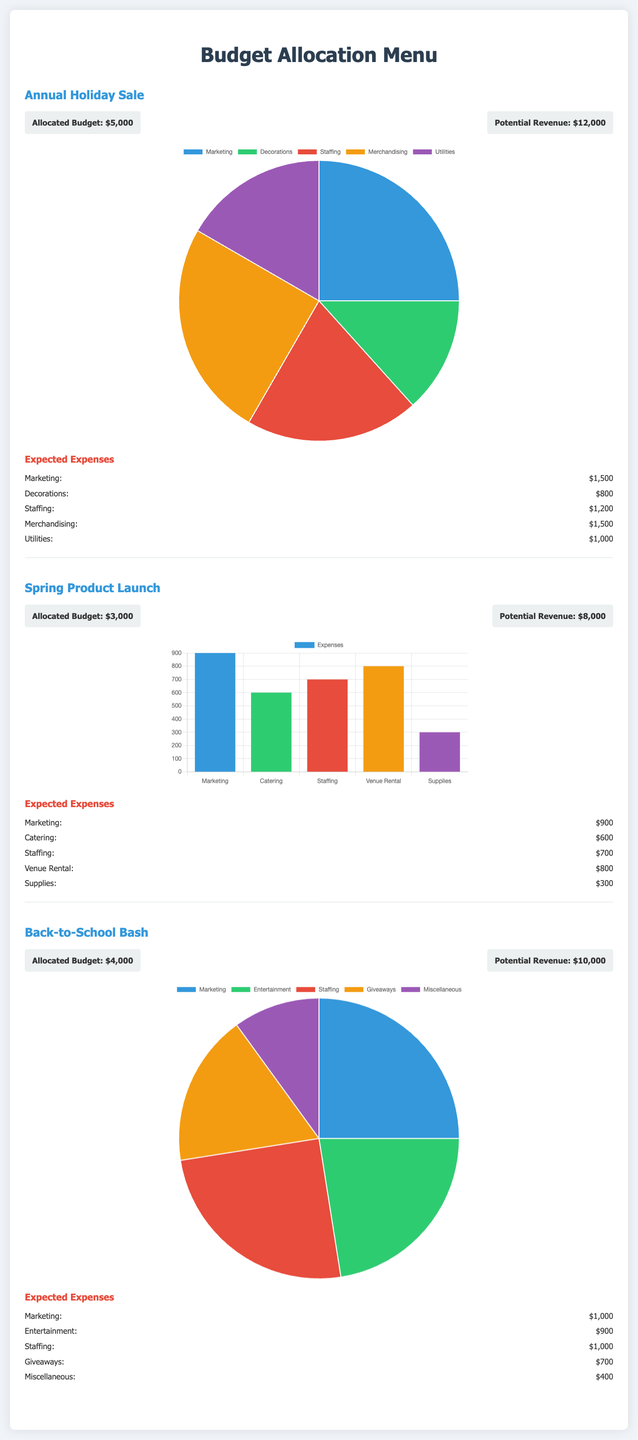what is the allocated budget for the Annual Holiday Sale? The allocated budget is specified under the Annual Holiday Sale section, shown as $5,000.
Answer: $5,000 what is the potential revenue for the Spring Product Launch? The potential revenue is listed under the Spring Product Launch section, which states $8,000.
Answer: $8,000 how much is allocated for staffing in the Back-to-School Bash? The amount for staffing in the Back-to-School Bash is provided in the expected expenses as $1,000.
Answer: $1,000 what percentage of the budget is spent on marketing for the Annual Holiday Sale? The pie chart shows that marketing takes up 30% of the budget allocation for the Annual Holiday Sale.
Answer: 30% what is the total expected expense for the Spring Product Launch? The total expected expenses can be calculated by adding all specified expenses in the Spring Product Launch section, resulting in $3,600.
Answer: $3,600 which event has the lowest allocated budget? By comparing the allocated budgets, the Spring Product Launch has the lowest budget of $3,000.
Answer: $3,000 what type of chart is used for the Back-to-School Bash? The type of chart for the Back-to-School Bash is specified as a pie chart.
Answer: pie chart how much is allocated for decorations in the Annual Holiday Sale? The expected expense for decorations in the Annual Holiday Sale is specified as $800.
Answer: $800 which expense category has the highest amount for the Spring Product Launch? The expense category with the highest amount in the Spring Product Launch is venue rental, with $800.
Answer: venue rental 